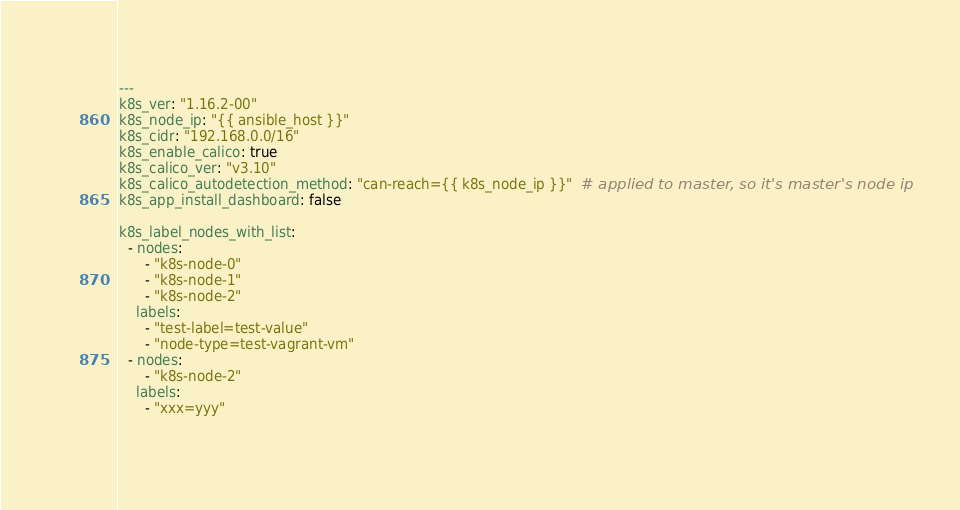<code> <loc_0><loc_0><loc_500><loc_500><_YAML_>---
k8s_ver: "1.16.2-00"
k8s_node_ip: "{{ ansible_host }}"
k8s_cidr: "192.168.0.0/16"
k8s_enable_calico: true
k8s_calico_ver: "v3.10"
k8s_calico_autodetection_method: "can-reach={{ k8s_node_ip }}"  # applied to master, so it's master's node ip
k8s_app_install_dashboard: false

k8s_label_nodes_with_list:
  - nodes:
      - "k8s-node-0"
      - "k8s-node-1"
      - "k8s-node-2"
    labels:
      - "test-label=test-value"
      - "node-type=test-vagrant-vm"
  - nodes:
      - "k8s-node-2"
    labels:
      - "xxx=yyy"
      
</code> 